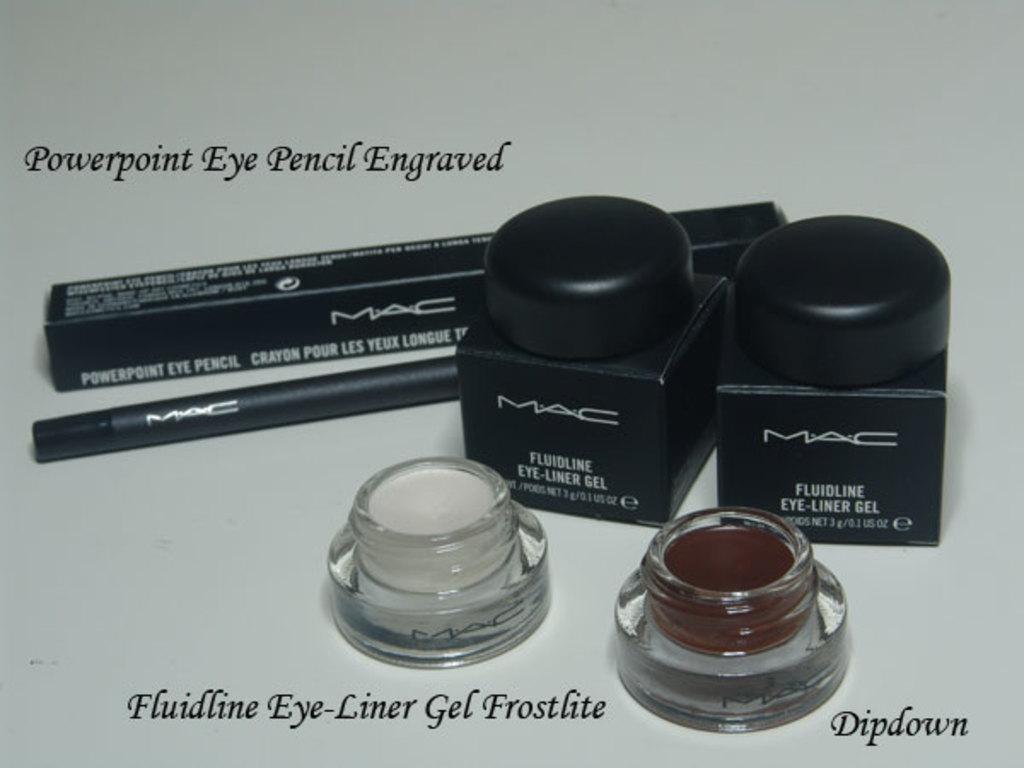<image>
Write a terse but informative summary of the picture. Eyeliner products from the makeup company Mac with an eye pencil 